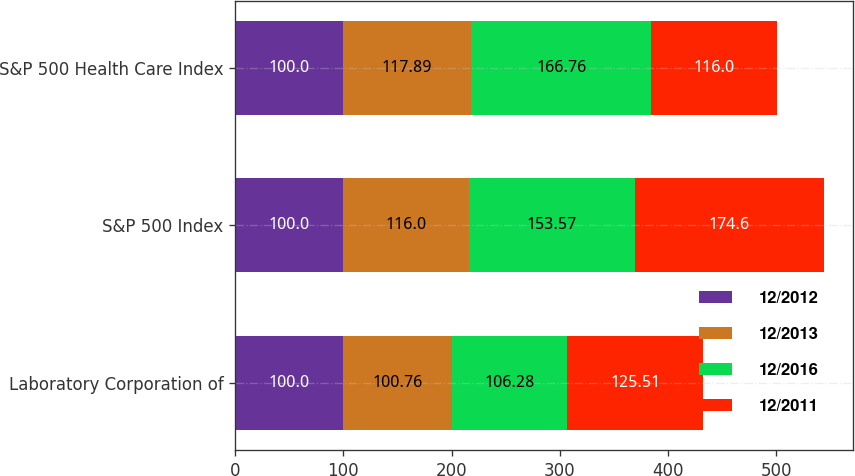Convert chart. <chart><loc_0><loc_0><loc_500><loc_500><stacked_bar_chart><ecel><fcel>Laboratory Corporation of<fcel>S&P 500 Index<fcel>S&P 500 Health Care Index<nl><fcel>12/2012<fcel>100<fcel>100<fcel>100<nl><fcel>12/2013<fcel>100.76<fcel>116<fcel>117.89<nl><fcel>12/2016<fcel>106.28<fcel>153.57<fcel>166.76<nl><fcel>12/2011<fcel>125.51<fcel>174.6<fcel>116<nl></chart> 